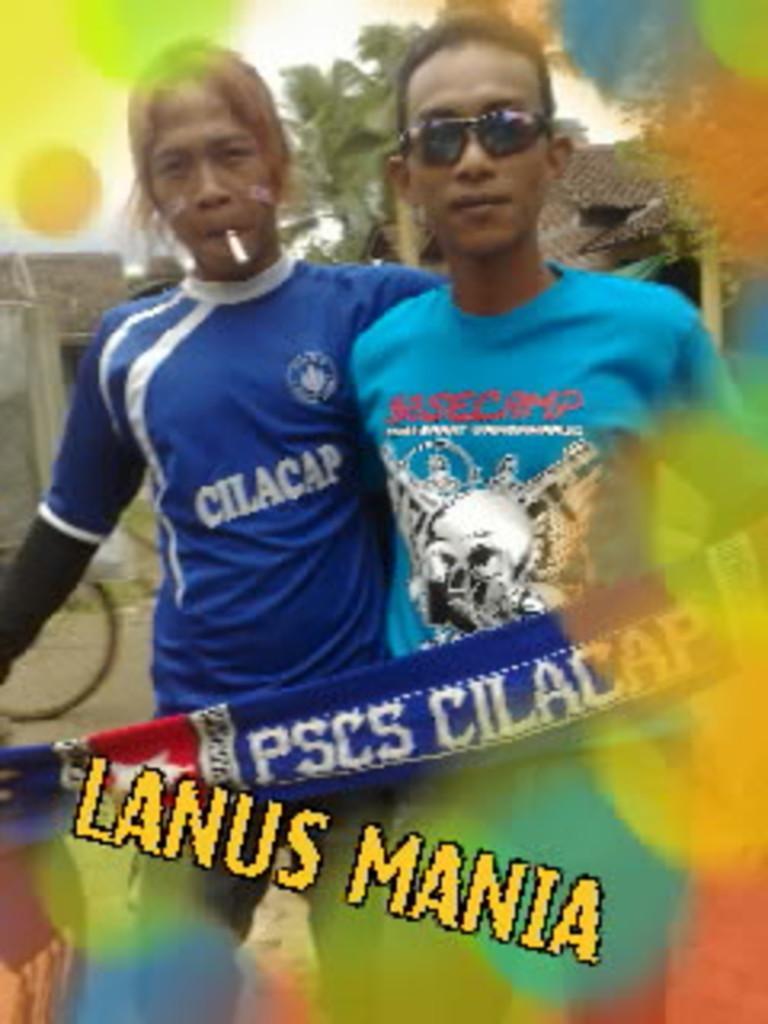Describe this image in one or two sentences. There is a person in violet color t-shirt. Beside him, there is a person in blue color t-shirt. In front of them, there is a violet color cloth and there is a watermark. In the background, there are trees, buildings and there is sky. 